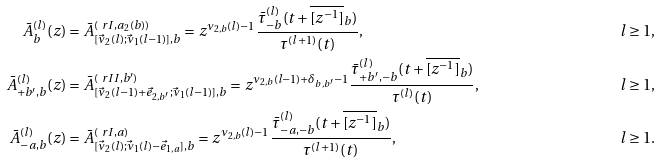Convert formula to latex. <formula><loc_0><loc_0><loc_500><loc_500>\bar { A } _ { b } ^ { ( l ) } ( z ) & = \bar { A } ^ { ( \ r I , a _ { 2 } ( b ) ) } _ { [ \vec { \nu } _ { 2 } ( l ) ; \vec { \nu } _ { 1 } ( l - 1 ) ] , b } = z ^ { \nu _ { 2 , b } ( l ) - 1 } \frac { \bar { \tau } _ { - b } ^ { ( l ) } ( t + \overline { [ z ^ { - 1 } ] } _ { b } ) } { \tau ^ { ( l + 1 ) } ( t ) } , & l \geq 1 , \\ \bar { A } _ { + b ^ { \prime } , b } ^ { ( l ) } ( z ) & = \bar { A } ^ { ( \ r I I , b ^ { \prime } ) } _ { [ \vec { \nu } _ { 2 } ( l - 1 ) + \vec { e } _ { 2 , b ^ { \prime } } ; \vec { \nu } _ { 1 } ( l - 1 ) ] , b } = z ^ { \nu _ { 2 , b } ( l - 1 ) + \delta _ { b , b ^ { \prime } } - 1 } \frac { \bar { \tau } _ { + b ^ { \prime } , - b } ^ { ( l ) } ( t + \overline { [ z ^ { - 1 } ] } _ { b } ) } { \tau ^ { ( l ) } ( t ) } , & l \geq 1 , \\ \bar { A } _ { - a , b } ^ { ( l ) } ( z ) & = \bar { A } ^ { ( \ r I , a ) } _ { [ \vec { \nu } _ { 2 } ( l ) ; \vec { \nu } _ { 1 } ( l ) - \vec { e } _ { 1 , a } ] , b } = z ^ { \nu _ { 2 , b } ( l ) - 1 } \frac { \bar { \tau } ^ { ( l ) } _ { - a , - b } ( t + \overline { [ z ^ { - 1 } ] } _ { b } ) } { \tau ^ { ( l + 1 ) } ( t ) } , & l \geq 1 .</formula> 